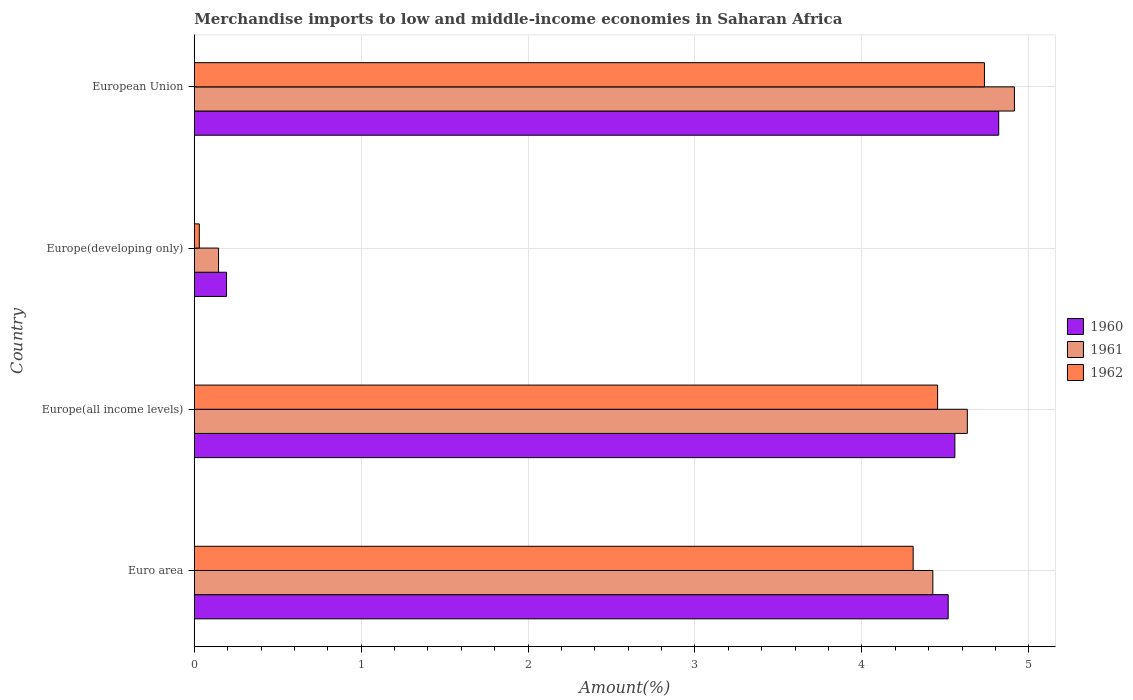Are the number of bars per tick equal to the number of legend labels?
Give a very brief answer. Yes. How many bars are there on the 2nd tick from the bottom?
Your answer should be very brief. 3. What is the label of the 1st group of bars from the top?
Your answer should be very brief. European Union. What is the percentage of amount earned from merchandise imports in 1961 in Europe(all income levels)?
Your response must be concise. 4.63. Across all countries, what is the maximum percentage of amount earned from merchandise imports in 1960?
Keep it short and to the point. 4.82. Across all countries, what is the minimum percentage of amount earned from merchandise imports in 1961?
Provide a succinct answer. 0.15. In which country was the percentage of amount earned from merchandise imports in 1962 maximum?
Give a very brief answer. European Union. In which country was the percentage of amount earned from merchandise imports in 1962 minimum?
Offer a terse response. Europe(developing only). What is the total percentage of amount earned from merchandise imports in 1961 in the graph?
Offer a terse response. 14.12. What is the difference between the percentage of amount earned from merchandise imports in 1962 in Europe(developing only) and that in European Union?
Keep it short and to the point. -4.7. What is the difference between the percentage of amount earned from merchandise imports in 1962 in Euro area and the percentage of amount earned from merchandise imports in 1960 in Europe(developing only)?
Offer a very short reply. 4.11. What is the average percentage of amount earned from merchandise imports in 1961 per country?
Keep it short and to the point. 3.53. What is the difference between the percentage of amount earned from merchandise imports in 1960 and percentage of amount earned from merchandise imports in 1962 in European Union?
Give a very brief answer. 0.09. What is the ratio of the percentage of amount earned from merchandise imports in 1962 in Europe(all income levels) to that in European Union?
Your response must be concise. 0.94. Is the difference between the percentage of amount earned from merchandise imports in 1960 in Europe(all income levels) and European Union greater than the difference between the percentage of amount earned from merchandise imports in 1962 in Europe(all income levels) and European Union?
Provide a short and direct response. Yes. What is the difference between the highest and the second highest percentage of amount earned from merchandise imports in 1960?
Make the answer very short. 0.26. What is the difference between the highest and the lowest percentage of amount earned from merchandise imports in 1962?
Keep it short and to the point. 4.7. In how many countries, is the percentage of amount earned from merchandise imports in 1962 greater than the average percentage of amount earned from merchandise imports in 1962 taken over all countries?
Your answer should be compact. 3. Is the sum of the percentage of amount earned from merchandise imports in 1960 in Europe(all income levels) and Europe(developing only) greater than the maximum percentage of amount earned from merchandise imports in 1961 across all countries?
Offer a terse response. No. Are the values on the major ticks of X-axis written in scientific E-notation?
Offer a very short reply. No. Where does the legend appear in the graph?
Keep it short and to the point. Center right. What is the title of the graph?
Provide a succinct answer. Merchandise imports to low and middle-income economies in Saharan Africa. What is the label or title of the X-axis?
Keep it short and to the point. Amount(%). What is the label or title of the Y-axis?
Give a very brief answer. Country. What is the Amount(%) in 1960 in Euro area?
Ensure brevity in your answer.  4.52. What is the Amount(%) in 1961 in Euro area?
Your response must be concise. 4.43. What is the Amount(%) in 1962 in Euro area?
Offer a very short reply. 4.31. What is the Amount(%) in 1960 in Europe(all income levels)?
Provide a short and direct response. 4.56. What is the Amount(%) of 1961 in Europe(all income levels)?
Your answer should be compact. 4.63. What is the Amount(%) in 1962 in Europe(all income levels)?
Provide a short and direct response. 4.45. What is the Amount(%) in 1960 in Europe(developing only)?
Your answer should be very brief. 0.19. What is the Amount(%) of 1961 in Europe(developing only)?
Provide a succinct answer. 0.15. What is the Amount(%) in 1962 in Europe(developing only)?
Your answer should be compact. 0.03. What is the Amount(%) of 1960 in European Union?
Offer a terse response. 4.82. What is the Amount(%) in 1961 in European Union?
Provide a short and direct response. 4.91. What is the Amount(%) in 1962 in European Union?
Ensure brevity in your answer.  4.73. Across all countries, what is the maximum Amount(%) in 1960?
Provide a short and direct response. 4.82. Across all countries, what is the maximum Amount(%) in 1961?
Offer a very short reply. 4.91. Across all countries, what is the maximum Amount(%) of 1962?
Offer a terse response. 4.73. Across all countries, what is the minimum Amount(%) in 1960?
Your answer should be very brief. 0.19. Across all countries, what is the minimum Amount(%) of 1961?
Ensure brevity in your answer.  0.15. Across all countries, what is the minimum Amount(%) of 1962?
Provide a short and direct response. 0.03. What is the total Amount(%) in 1960 in the graph?
Make the answer very short. 14.09. What is the total Amount(%) in 1961 in the graph?
Your answer should be very brief. 14.12. What is the total Amount(%) in 1962 in the graph?
Provide a short and direct response. 13.53. What is the difference between the Amount(%) in 1960 in Euro area and that in Europe(all income levels)?
Offer a very short reply. -0.04. What is the difference between the Amount(%) of 1961 in Euro area and that in Europe(all income levels)?
Keep it short and to the point. -0.21. What is the difference between the Amount(%) in 1962 in Euro area and that in Europe(all income levels)?
Offer a very short reply. -0.15. What is the difference between the Amount(%) of 1960 in Euro area and that in Europe(developing only)?
Offer a very short reply. 4.32. What is the difference between the Amount(%) of 1961 in Euro area and that in Europe(developing only)?
Give a very brief answer. 4.28. What is the difference between the Amount(%) of 1962 in Euro area and that in Europe(developing only)?
Offer a very short reply. 4.28. What is the difference between the Amount(%) of 1960 in Euro area and that in European Union?
Provide a succinct answer. -0.3. What is the difference between the Amount(%) in 1961 in Euro area and that in European Union?
Your answer should be very brief. -0.49. What is the difference between the Amount(%) in 1962 in Euro area and that in European Union?
Give a very brief answer. -0.43. What is the difference between the Amount(%) of 1960 in Europe(all income levels) and that in Europe(developing only)?
Make the answer very short. 4.36. What is the difference between the Amount(%) in 1961 in Europe(all income levels) and that in Europe(developing only)?
Ensure brevity in your answer.  4.49. What is the difference between the Amount(%) in 1962 in Europe(all income levels) and that in Europe(developing only)?
Make the answer very short. 4.42. What is the difference between the Amount(%) of 1960 in Europe(all income levels) and that in European Union?
Provide a succinct answer. -0.26. What is the difference between the Amount(%) of 1961 in Europe(all income levels) and that in European Union?
Your answer should be very brief. -0.28. What is the difference between the Amount(%) of 1962 in Europe(all income levels) and that in European Union?
Your response must be concise. -0.28. What is the difference between the Amount(%) in 1960 in Europe(developing only) and that in European Union?
Provide a succinct answer. -4.63. What is the difference between the Amount(%) of 1961 in Europe(developing only) and that in European Union?
Ensure brevity in your answer.  -4.77. What is the difference between the Amount(%) of 1962 in Europe(developing only) and that in European Union?
Keep it short and to the point. -4.7. What is the difference between the Amount(%) in 1960 in Euro area and the Amount(%) in 1961 in Europe(all income levels)?
Provide a short and direct response. -0.11. What is the difference between the Amount(%) in 1960 in Euro area and the Amount(%) in 1962 in Europe(all income levels)?
Keep it short and to the point. 0.06. What is the difference between the Amount(%) of 1961 in Euro area and the Amount(%) of 1962 in Europe(all income levels)?
Keep it short and to the point. -0.03. What is the difference between the Amount(%) of 1960 in Euro area and the Amount(%) of 1961 in Europe(developing only)?
Your response must be concise. 4.37. What is the difference between the Amount(%) of 1960 in Euro area and the Amount(%) of 1962 in Europe(developing only)?
Provide a short and direct response. 4.49. What is the difference between the Amount(%) in 1961 in Euro area and the Amount(%) in 1962 in Europe(developing only)?
Offer a terse response. 4.39. What is the difference between the Amount(%) of 1960 in Euro area and the Amount(%) of 1961 in European Union?
Your answer should be very brief. -0.4. What is the difference between the Amount(%) of 1960 in Euro area and the Amount(%) of 1962 in European Union?
Your answer should be compact. -0.22. What is the difference between the Amount(%) in 1961 in Euro area and the Amount(%) in 1962 in European Union?
Make the answer very short. -0.31. What is the difference between the Amount(%) in 1960 in Europe(all income levels) and the Amount(%) in 1961 in Europe(developing only)?
Your answer should be compact. 4.41. What is the difference between the Amount(%) of 1960 in Europe(all income levels) and the Amount(%) of 1962 in Europe(developing only)?
Give a very brief answer. 4.53. What is the difference between the Amount(%) in 1961 in Europe(all income levels) and the Amount(%) in 1962 in Europe(developing only)?
Make the answer very short. 4.6. What is the difference between the Amount(%) in 1960 in Europe(all income levels) and the Amount(%) in 1961 in European Union?
Provide a short and direct response. -0.36. What is the difference between the Amount(%) of 1960 in Europe(all income levels) and the Amount(%) of 1962 in European Union?
Your response must be concise. -0.18. What is the difference between the Amount(%) of 1961 in Europe(all income levels) and the Amount(%) of 1962 in European Union?
Provide a succinct answer. -0.1. What is the difference between the Amount(%) in 1960 in Europe(developing only) and the Amount(%) in 1961 in European Union?
Offer a very short reply. -4.72. What is the difference between the Amount(%) in 1960 in Europe(developing only) and the Amount(%) in 1962 in European Union?
Provide a succinct answer. -4.54. What is the difference between the Amount(%) of 1961 in Europe(developing only) and the Amount(%) of 1962 in European Union?
Make the answer very short. -4.59. What is the average Amount(%) of 1960 per country?
Provide a succinct answer. 3.52. What is the average Amount(%) in 1961 per country?
Give a very brief answer. 3.53. What is the average Amount(%) of 1962 per country?
Make the answer very short. 3.38. What is the difference between the Amount(%) of 1960 and Amount(%) of 1961 in Euro area?
Provide a succinct answer. 0.09. What is the difference between the Amount(%) in 1960 and Amount(%) in 1962 in Euro area?
Offer a very short reply. 0.21. What is the difference between the Amount(%) of 1961 and Amount(%) of 1962 in Euro area?
Provide a succinct answer. 0.12. What is the difference between the Amount(%) of 1960 and Amount(%) of 1961 in Europe(all income levels)?
Your answer should be compact. -0.07. What is the difference between the Amount(%) in 1960 and Amount(%) in 1962 in Europe(all income levels)?
Make the answer very short. 0.1. What is the difference between the Amount(%) of 1961 and Amount(%) of 1962 in Europe(all income levels)?
Your response must be concise. 0.18. What is the difference between the Amount(%) of 1960 and Amount(%) of 1961 in Europe(developing only)?
Provide a succinct answer. 0.05. What is the difference between the Amount(%) in 1960 and Amount(%) in 1962 in Europe(developing only)?
Keep it short and to the point. 0.16. What is the difference between the Amount(%) of 1961 and Amount(%) of 1962 in Europe(developing only)?
Your answer should be compact. 0.12. What is the difference between the Amount(%) in 1960 and Amount(%) in 1961 in European Union?
Ensure brevity in your answer.  -0.09. What is the difference between the Amount(%) in 1960 and Amount(%) in 1962 in European Union?
Keep it short and to the point. 0.09. What is the difference between the Amount(%) in 1961 and Amount(%) in 1962 in European Union?
Give a very brief answer. 0.18. What is the ratio of the Amount(%) of 1961 in Euro area to that in Europe(all income levels)?
Offer a very short reply. 0.96. What is the ratio of the Amount(%) in 1962 in Euro area to that in Europe(all income levels)?
Provide a short and direct response. 0.97. What is the ratio of the Amount(%) in 1960 in Euro area to that in Europe(developing only)?
Offer a very short reply. 23.36. What is the ratio of the Amount(%) in 1961 in Euro area to that in Europe(developing only)?
Offer a terse response. 30.42. What is the ratio of the Amount(%) of 1962 in Euro area to that in Europe(developing only)?
Keep it short and to the point. 142.3. What is the ratio of the Amount(%) of 1960 in Euro area to that in European Union?
Give a very brief answer. 0.94. What is the ratio of the Amount(%) of 1961 in Euro area to that in European Union?
Your answer should be compact. 0.9. What is the ratio of the Amount(%) in 1962 in Euro area to that in European Union?
Your answer should be very brief. 0.91. What is the ratio of the Amount(%) in 1960 in Europe(all income levels) to that in Europe(developing only)?
Keep it short and to the point. 23.56. What is the ratio of the Amount(%) of 1961 in Europe(all income levels) to that in Europe(developing only)?
Your response must be concise. 31.84. What is the ratio of the Amount(%) of 1962 in Europe(all income levels) to that in Europe(developing only)?
Keep it short and to the point. 147.14. What is the ratio of the Amount(%) in 1960 in Europe(all income levels) to that in European Union?
Offer a very short reply. 0.95. What is the ratio of the Amount(%) of 1961 in Europe(all income levels) to that in European Union?
Your answer should be very brief. 0.94. What is the ratio of the Amount(%) in 1962 in Europe(all income levels) to that in European Union?
Your response must be concise. 0.94. What is the ratio of the Amount(%) of 1960 in Europe(developing only) to that in European Union?
Offer a terse response. 0.04. What is the ratio of the Amount(%) in 1961 in Europe(developing only) to that in European Union?
Offer a terse response. 0.03. What is the ratio of the Amount(%) of 1962 in Europe(developing only) to that in European Union?
Your answer should be compact. 0.01. What is the difference between the highest and the second highest Amount(%) of 1960?
Your answer should be very brief. 0.26. What is the difference between the highest and the second highest Amount(%) in 1961?
Offer a terse response. 0.28. What is the difference between the highest and the second highest Amount(%) of 1962?
Make the answer very short. 0.28. What is the difference between the highest and the lowest Amount(%) in 1960?
Provide a short and direct response. 4.63. What is the difference between the highest and the lowest Amount(%) of 1961?
Your answer should be compact. 4.77. What is the difference between the highest and the lowest Amount(%) of 1962?
Offer a very short reply. 4.7. 